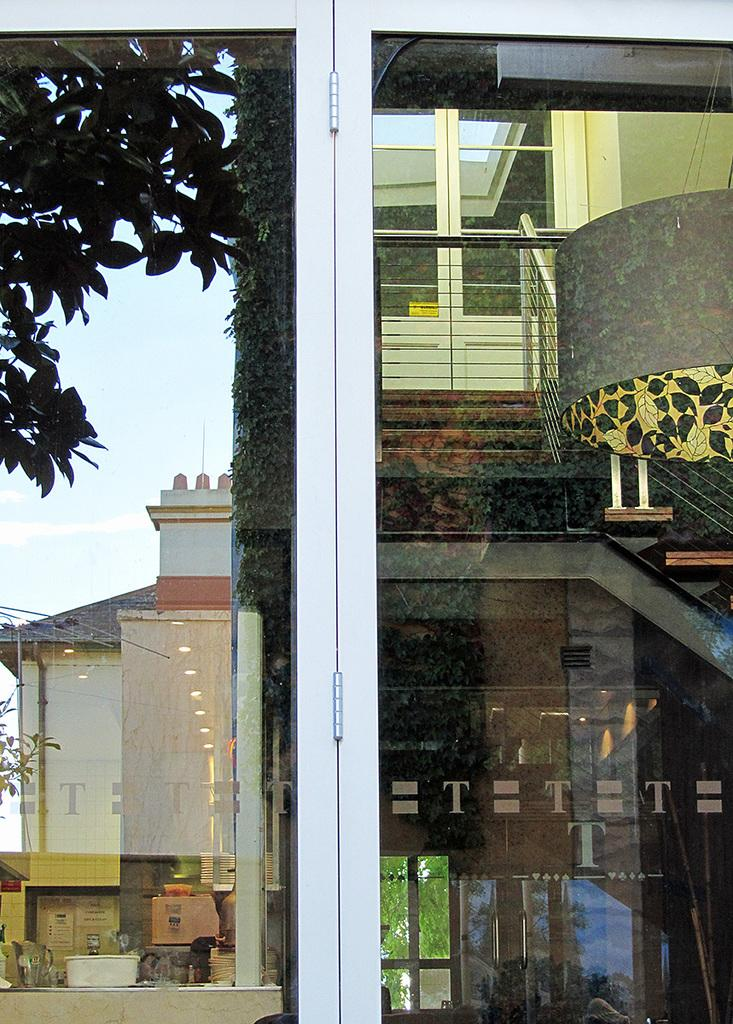How many windows are visible in the image? There are two windows in the image. What can be seen on the glass of the windows? The images of buildings, trees, and other items are being reflected on the glass of the windows. What is the limit of the song being played in the image? There is no song being played in the image; it only features two windows with reflections on their glass. 